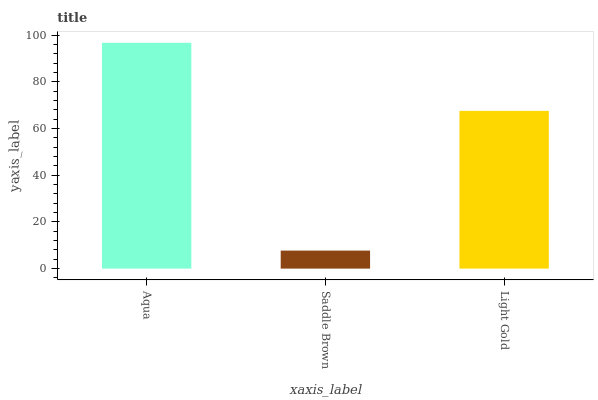Is Saddle Brown the minimum?
Answer yes or no. Yes. Is Aqua the maximum?
Answer yes or no. Yes. Is Light Gold the minimum?
Answer yes or no. No. Is Light Gold the maximum?
Answer yes or no. No. Is Light Gold greater than Saddle Brown?
Answer yes or no. Yes. Is Saddle Brown less than Light Gold?
Answer yes or no. Yes. Is Saddle Brown greater than Light Gold?
Answer yes or no. No. Is Light Gold less than Saddle Brown?
Answer yes or no. No. Is Light Gold the high median?
Answer yes or no. Yes. Is Light Gold the low median?
Answer yes or no. Yes. Is Aqua the high median?
Answer yes or no. No. Is Aqua the low median?
Answer yes or no. No. 